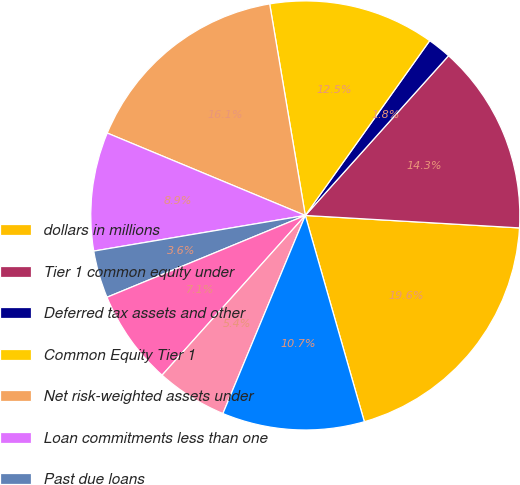Convert chart to OTSL. <chart><loc_0><loc_0><loc_500><loc_500><pie_chart><fcel>dollars in millions<fcel>Tier 1 common equity under<fcel>Deferred tax assets and other<fcel>Common Equity Tier 1<fcel>Net risk-weighted assets under<fcel>Loan commitments less than one<fcel>Past due loans<fcel>Mortgage servicing assets (i)<fcel>Deferred tax assets (i)<fcel>Other<nl><fcel>19.64%<fcel>14.29%<fcel>1.79%<fcel>12.5%<fcel>16.07%<fcel>8.93%<fcel>3.57%<fcel>7.14%<fcel>5.36%<fcel>10.71%<nl></chart> 